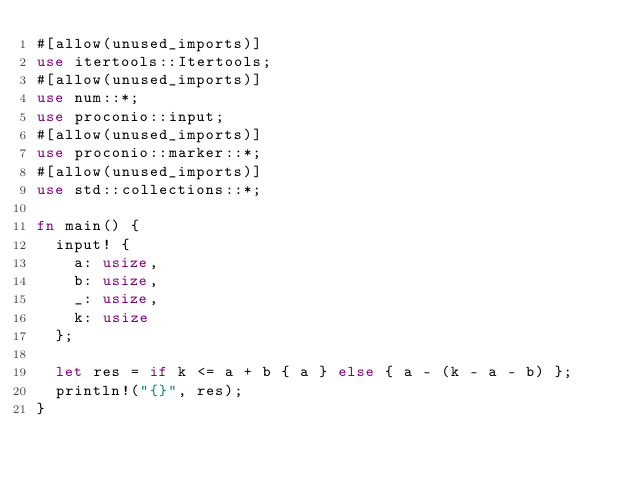<code> <loc_0><loc_0><loc_500><loc_500><_Rust_>#[allow(unused_imports)]
use itertools::Itertools;
#[allow(unused_imports)]
use num::*;
use proconio::input;
#[allow(unused_imports)]
use proconio::marker::*;
#[allow(unused_imports)]
use std::collections::*;

fn main() {
  input! {
    a: usize,
    b: usize,
    _: usize,
    k: usize
  };

  let res = if k <= a + b { a } else { a - (k - a - b) };
  println!("{}", res);
}
</code> 